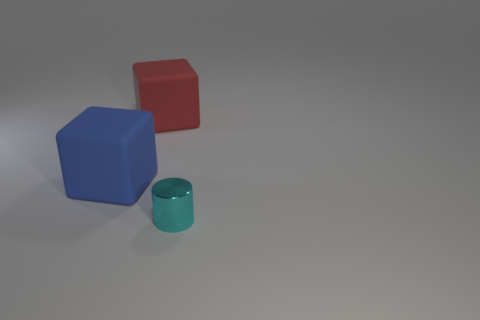The other thing that is the same shape as the blue thing is what color?
Keep it short and to the point. Red. The thing that is both left of the tiny cyan shiny object and in front of the red rubber thing has what shape?
Keep it short and to the point. Cube. What color is the big matte thing that is right of the large matte block that is in front of the large matte cube behind the blue cube?
Make the answer very short. Red. Is the number of cyan cylinders that are behind the blue block less than the number of green balls?
Your answer should be very brief. No. Is the shape of the big object that is in front of the red cube the same as the object on the right side of the red matte object?
Give a very brief answer. No. How many things are either objects that are behind the metal cylinder or tiny gray cubes?
Your answer should be compact. 2. There is a tiny cyan cylinder in front of the rubber thing that is on the left side of the red thing; is there a big red rubber thing that is in front of it?
Provide a short and direct response. No. Are there fewer tiny shiny objects that are to the left of the blue rubber cube than cyan things that are to the right of the cyan metallic cylinder?
Ensure brevity in your answer.  No. What is the color of the cube that is made of the same material as the red object?
Your answer should be compact. Blue. The big rubber cube that is in front of the matte object behind the blue thing is what color?
Provide a succinct answer. Blue. 